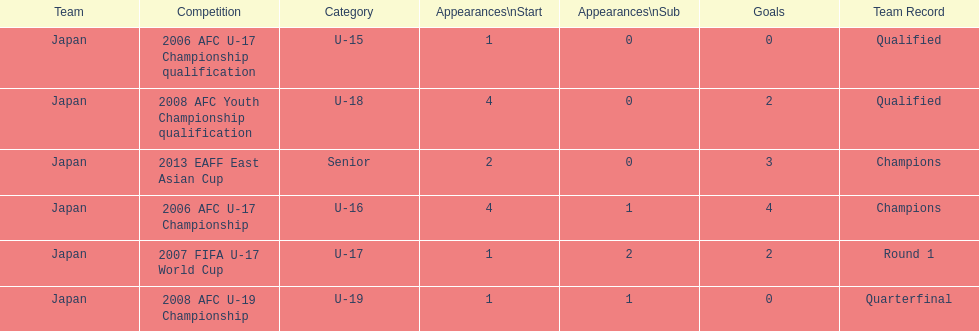Yoichiro kakitani scored above 2 goals in how many major competitions? 2. Could you parse the entire table as a dict? {'header': ['Team', 'Competition', 'Category', 'Appearances\\nStart', 'Appearances\\nSub', 'Goals', 'Team Record'], 'rows': [['Japan', '2006 AFC U-17 Championship qualification', 'U-15', '1', '0', '0', 'Qualified'], ['Japan', '2008 AFC Youth Championship qualification', 'U-18', '4', '0', '2', 'Qualified'], ['Japan', '2013 EAFF East Asian Cup', 'Senior', '2', '0', '3', 'Champions'], ['Japan', '2006 AFC U-17 Championship', 'U-16', '4', '1', '4', 'Champions'], ['Japan', '2007 FIFA U-17 World Cup', 'U-17', '1', '2', '2', 'Round 1'], ['Japan', '2008 AFC U-19 Championship', 'U-19', '1', '1', '0', 'Quarterfinal']]} 